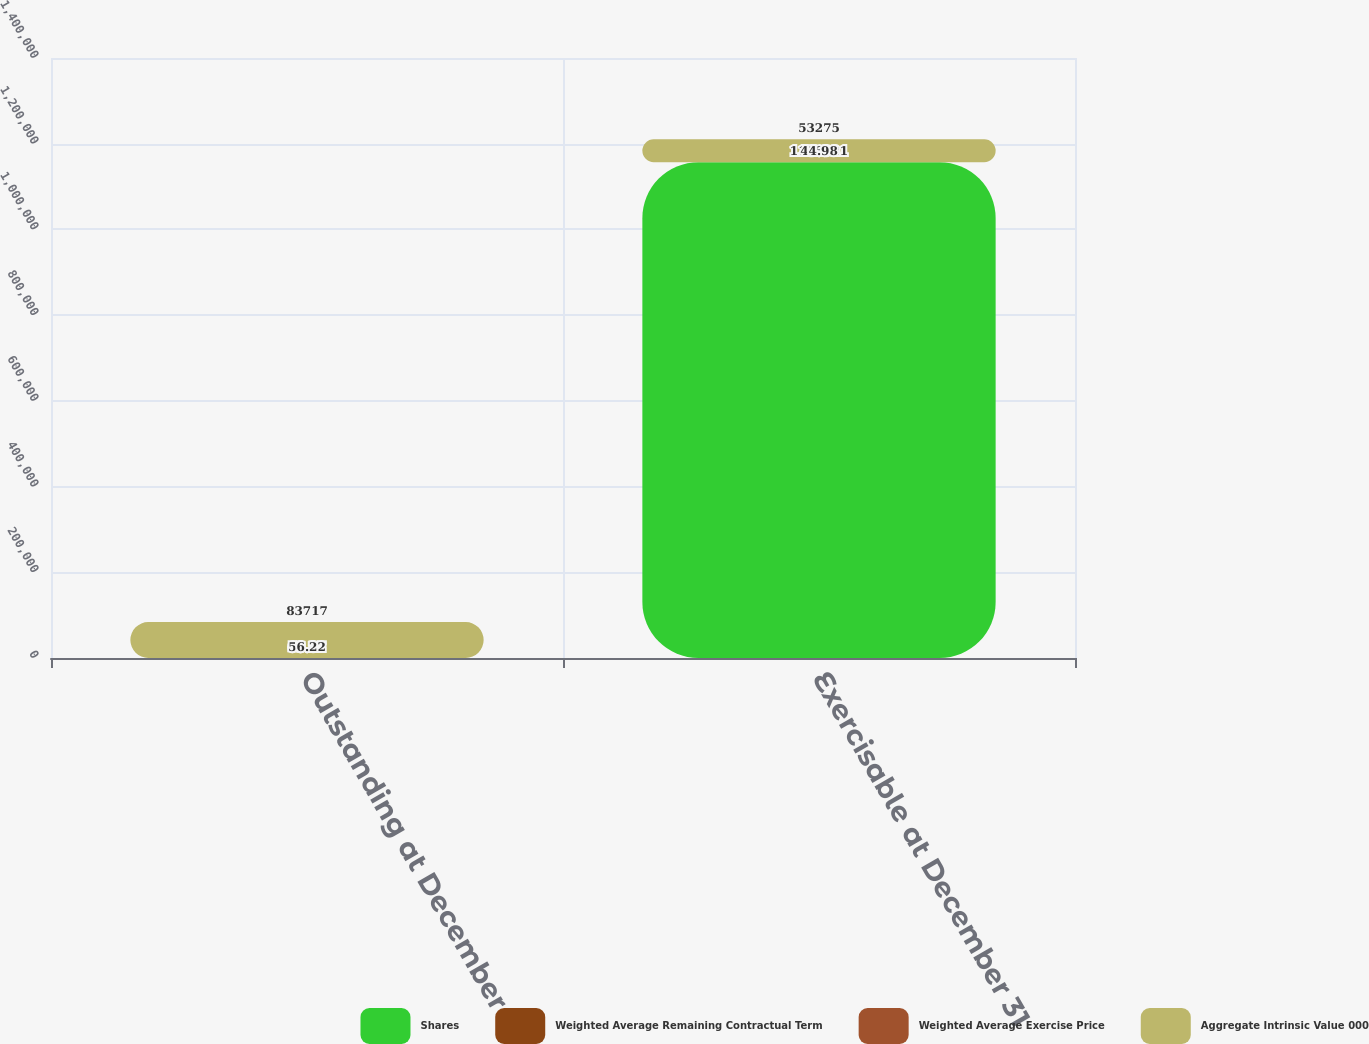Convert chart to OTSL. <chart><loc_0><loc_0><loc_500><loc_500><stacked_bar_chart><ecel><fcel>Outstanding at December 31<fcel>Exercisable at December 31<nl><fcel>Shares<fcel>63.27<fcel>1.15692e+06<nl><fcel>Weighted Average Remaining Contractual Term<fcel>53.82<fcel>43.88<nl><fcel>Weighted Average Exercise Price<fcel>6.2<fcel>4.9<nl><fcel>Aggregate Intrinsic Value 000<fcel>83717<fcel>53275<nl></chart> 